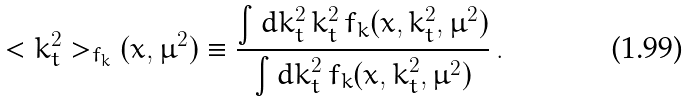Convert formula to latex. <formula><loc_0><loc_0><loc_500><loc_500>< k _ { t } ^ { 2 } > _ { f _ { k } } ( x , \mu ^ { 2 } ) \equiv \frac { \int d k _ { t } ^ { 2 } \, k _ { t } ^ { 2 } \, f _ { k } ( x , k _ { t } ^ { 2 } , \mu ^ { 2 } ) } { \int d k _ { t } ^ { 2 } \, f _ { k } ( x , k _ { t } ^ { 2 } , \mu ^ { 2 } ) } \, .</formula> 